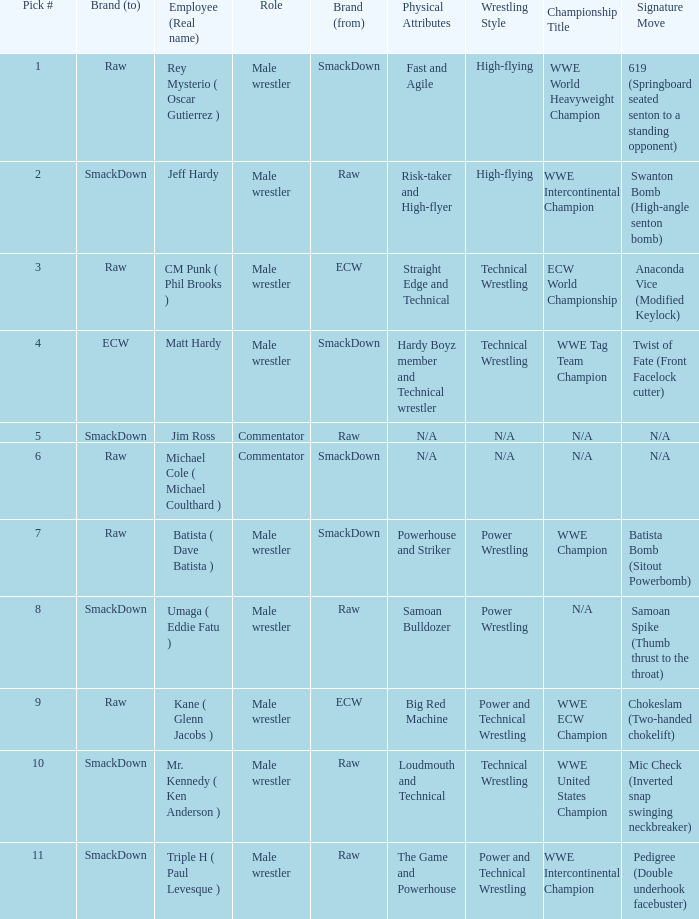Pick # 3 works for which brand? ECW. 